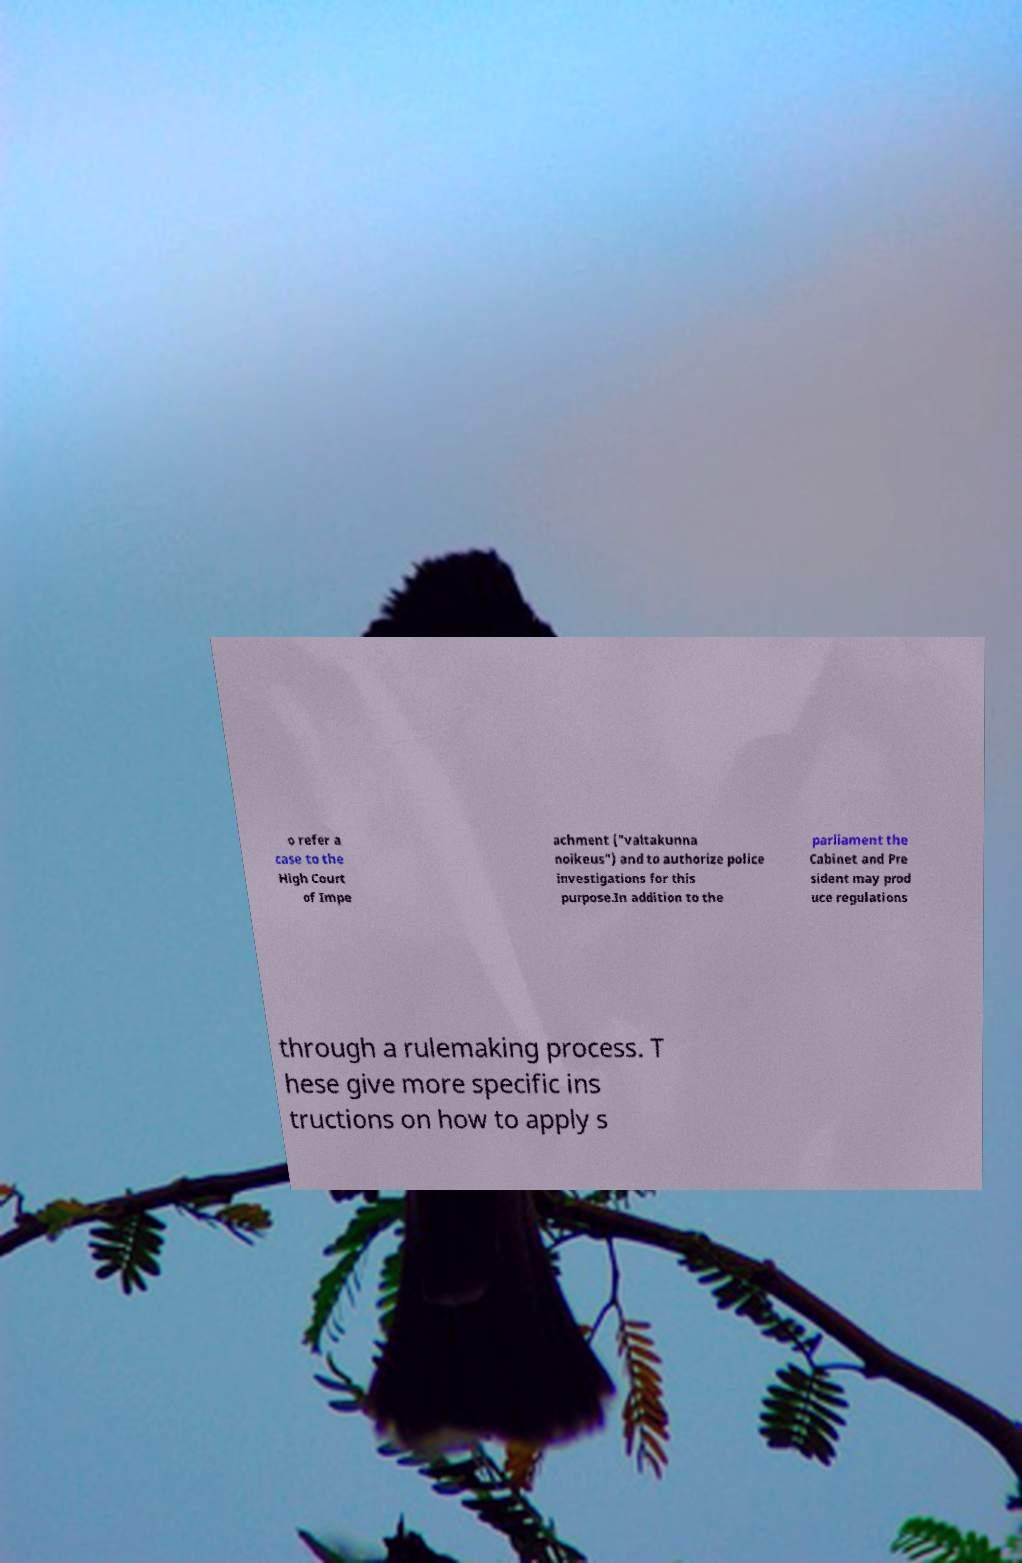I need the written content from this picture converted into text. Can you do that? o refer a case to the High Court of Impe achment ("valtakunna noikeus") and to authorize police investigations for this purpose.In addition to the parliament the Cabinet and Pre sident may prod uce regulations through a rulemaking process. T hese give more specific ins tructions on how to apply s 